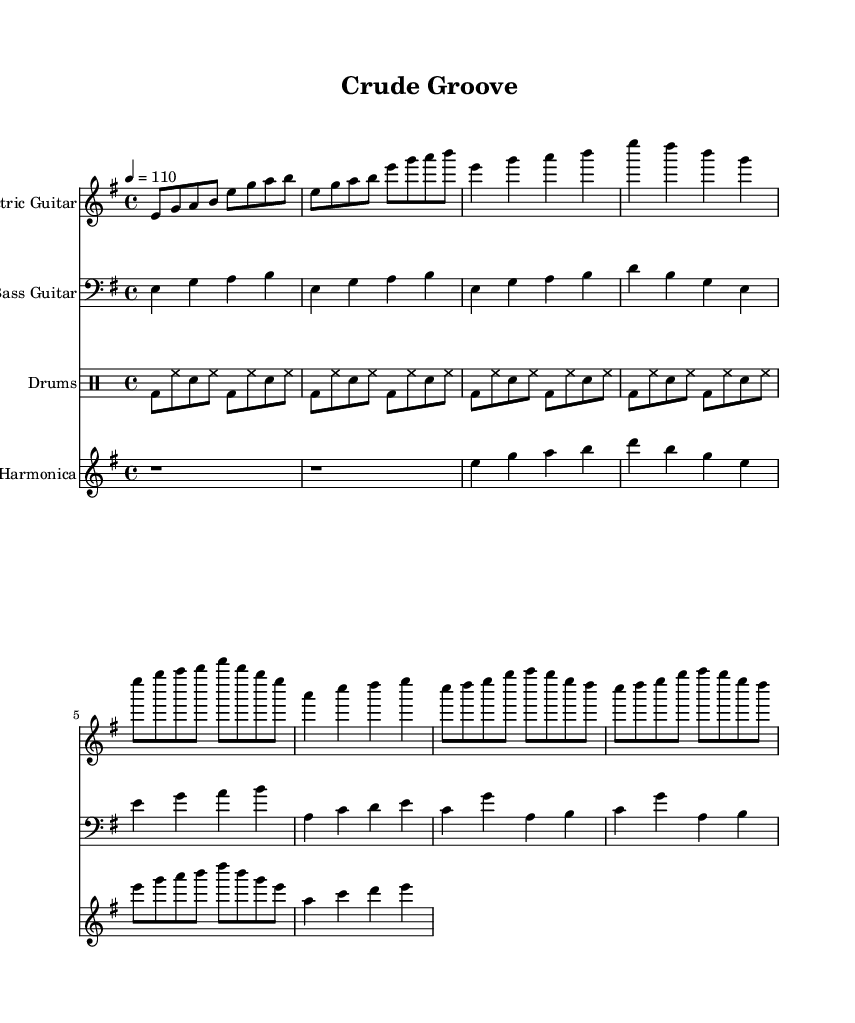what is the key signature of this music? The key signature is E minor, which has one sharp (F#). This can be determined by looking at the key signature indicated at the beginning of the score.
Answer: E minor what is the time signature of this music? The time signature is 4/4, meaning there are four beats in each measure and the quarter note gets one beat. This can be found at the beginning of the score below the key signature.
Answer: 4/4 what is the tempo marking of this music? The tempo marking is 110 beats per minute, indicated at the start of the piece. This shows the speed at which the piece should be played.
Answer: 110 which instrument has the highest pitch overall? The highest pitches are primarily found in the electric guitar part, which typically plays higher notes compared to the bass guitar and harmonica parts. By comparing the given notations, the electric guitar consistently plays notes in the higher octave range.
Answer: Electric Guitar how many measures are in the chorus section? The chorus section consists of two measures, as indicated by the musical notation in the score. It can be counted from the start of the chorus part to where it ends.
Answer: 2 what kind of rhythm pattern is used in the drums part? The drums part features a basic funk pattern, which is characterized by a kick drum on the beat followed by hi-hat and snare accents in between. This can be observed in the consistent drum notation throughout that section.
Answer: Funk pattern what is the total number of instruments featured in this piece? There are four instruments featured in this piece: Electric Guitar, Bass Guitar, Drums, and Harmonica. This is confirmed by counting the separate instrument staves indicated in the score.
Answer: 4 